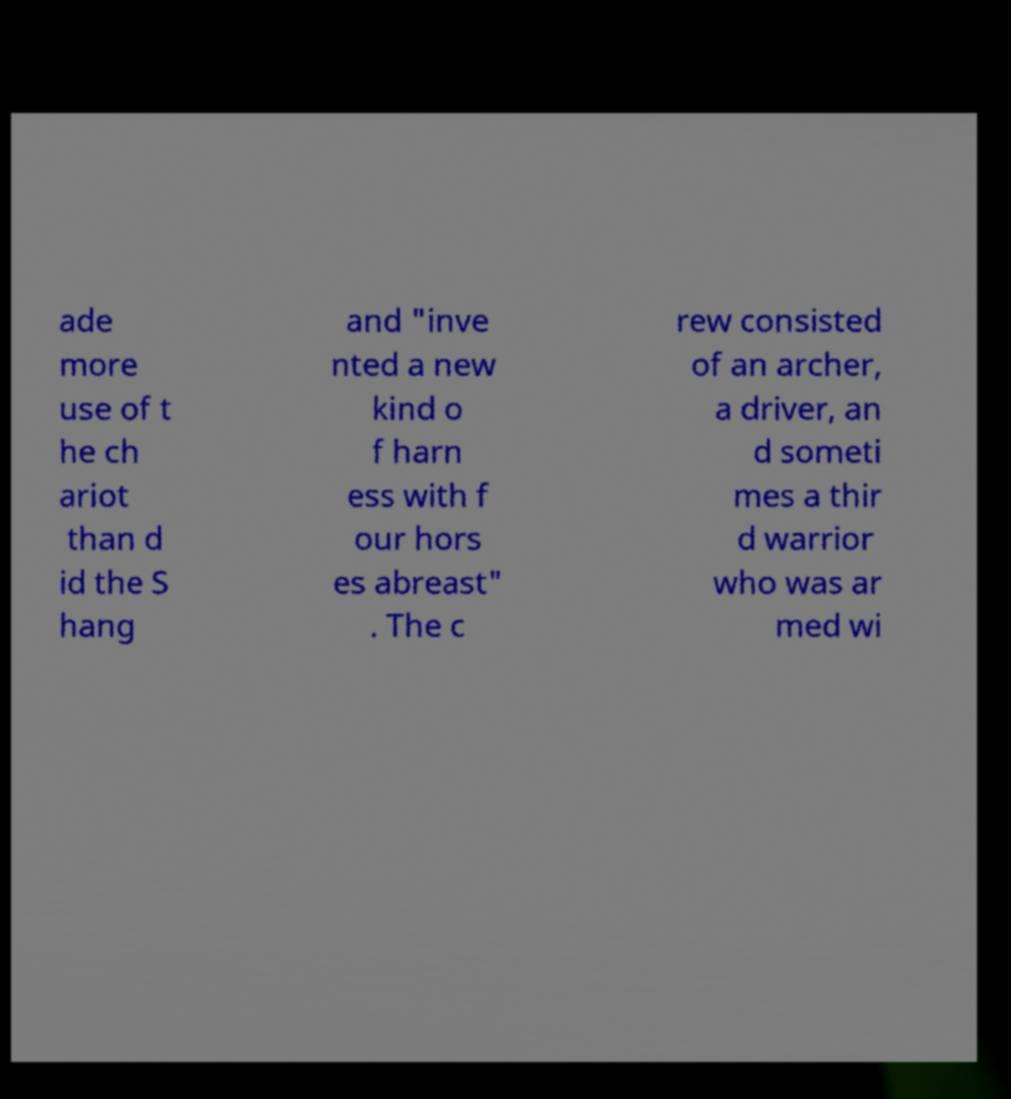What messages or text are displayed in this image? I need them in a readable, typed format. ade more use of t he ch ariot than d id the S hang and "inve nted a new kind o f harn ess with f our hors es abreast" . The c rew consisted of an archer, a driver, an d someti mes a thir d warrior who was ar med wi 